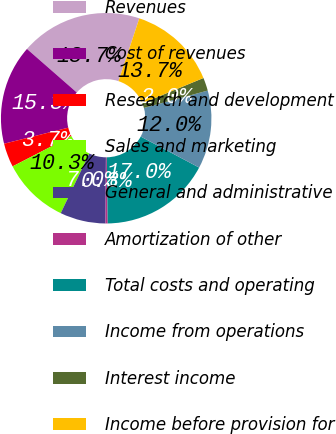<chart> <loc_0><loc_0><loc_500><loc_500><pie_chart><fcel>Revenues<fcel>Cost of revenues<fcel>Research and development<fcel>Sales and marketing<fcel>General and administrative<fcel>Amortization of other<fcel>Total costs and operating<fcel>Income from operations<fcel>Interest income<fcel>Income before provision for<nl><fcel>18.66%<fcel>15.33%<fcel>3.67%<fcel>10.33%<fcel>7.0%<fcel>0.34%<fcel>17.0%<fcel>12.0%<fcel>2.01%<fcel>13.66%<nl></chart> 